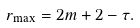Convert formula to latex. <formula><loc_0><loc_0><loc_500><loc_500>r _ { \max } = 2 m + 2 - \tau .</formula> 